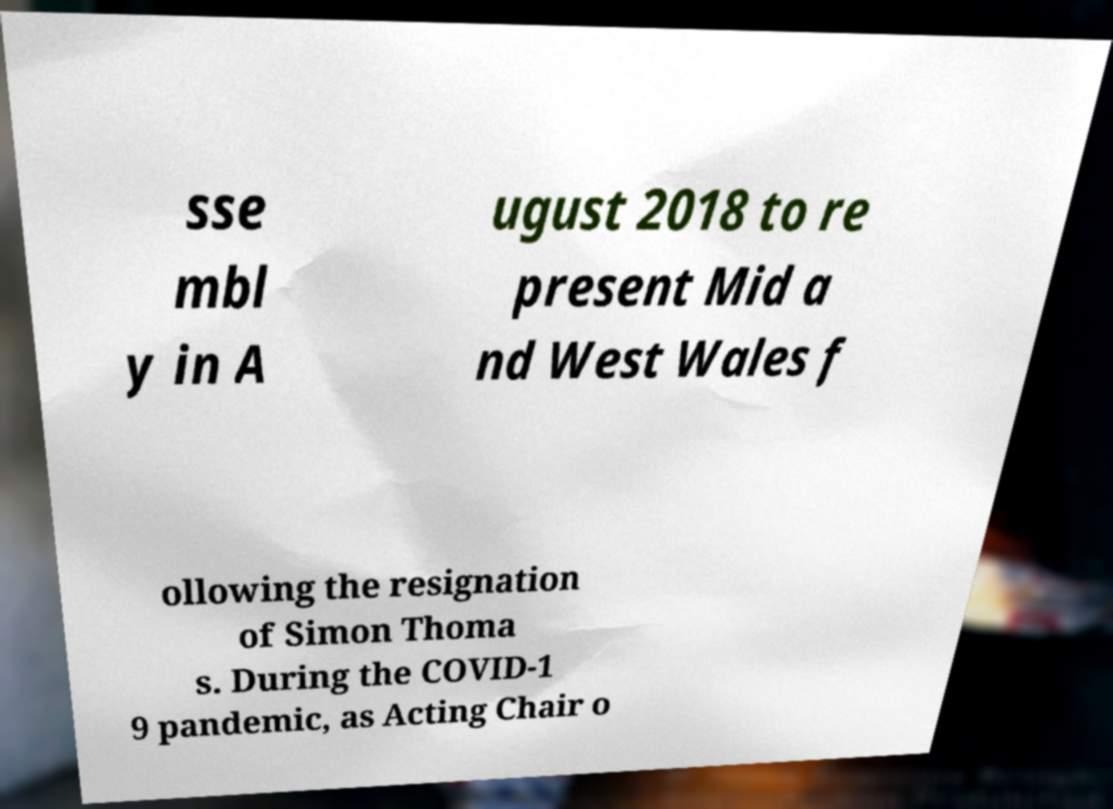Can you accurately transcribe the text from the provided image for me? sse mbl y in A ugust 2018 to re present Mid a nd West Wales f ollowing the resignation of Simon Thoma s. During the COVID-1 9 pandemic, as Acting Chair o 